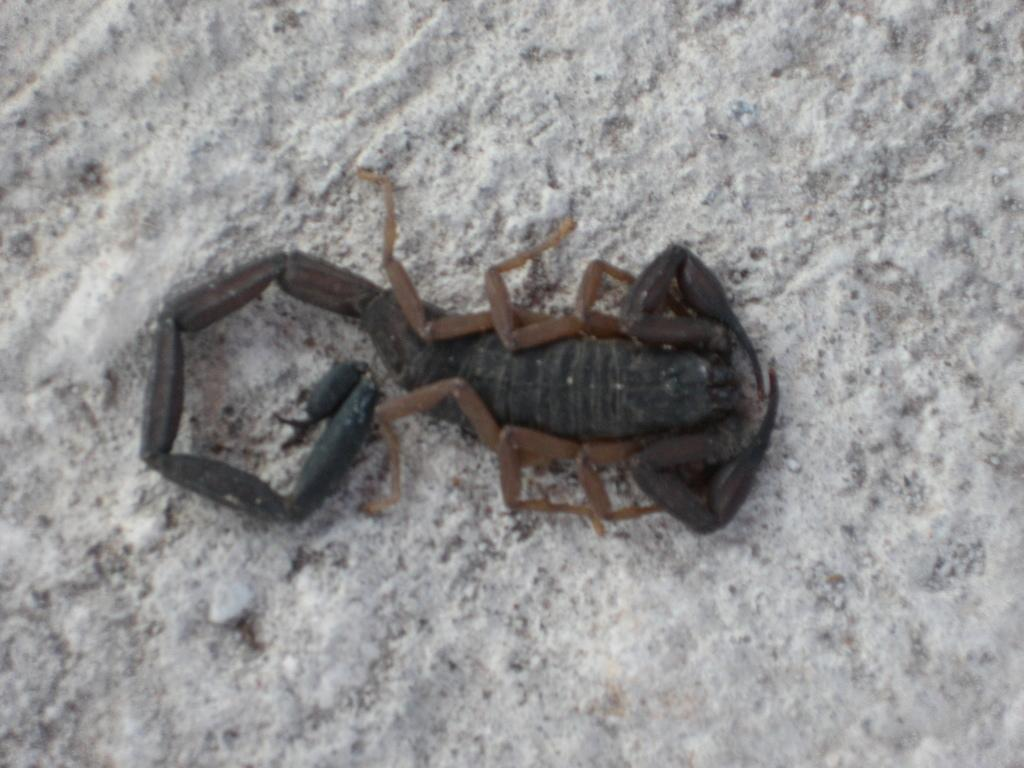What type of animal is in the image? There is a scorpion in the image. What color is the surface on which the scorpion is resting? The scorpion is on a white color surface. What type of society is depicted in the image? There is no society depicted in the image; it features a scorpion on a white surface. Is there a camp visible in the image? There is no camp present in the image; it features a scorpion on a white surface. 